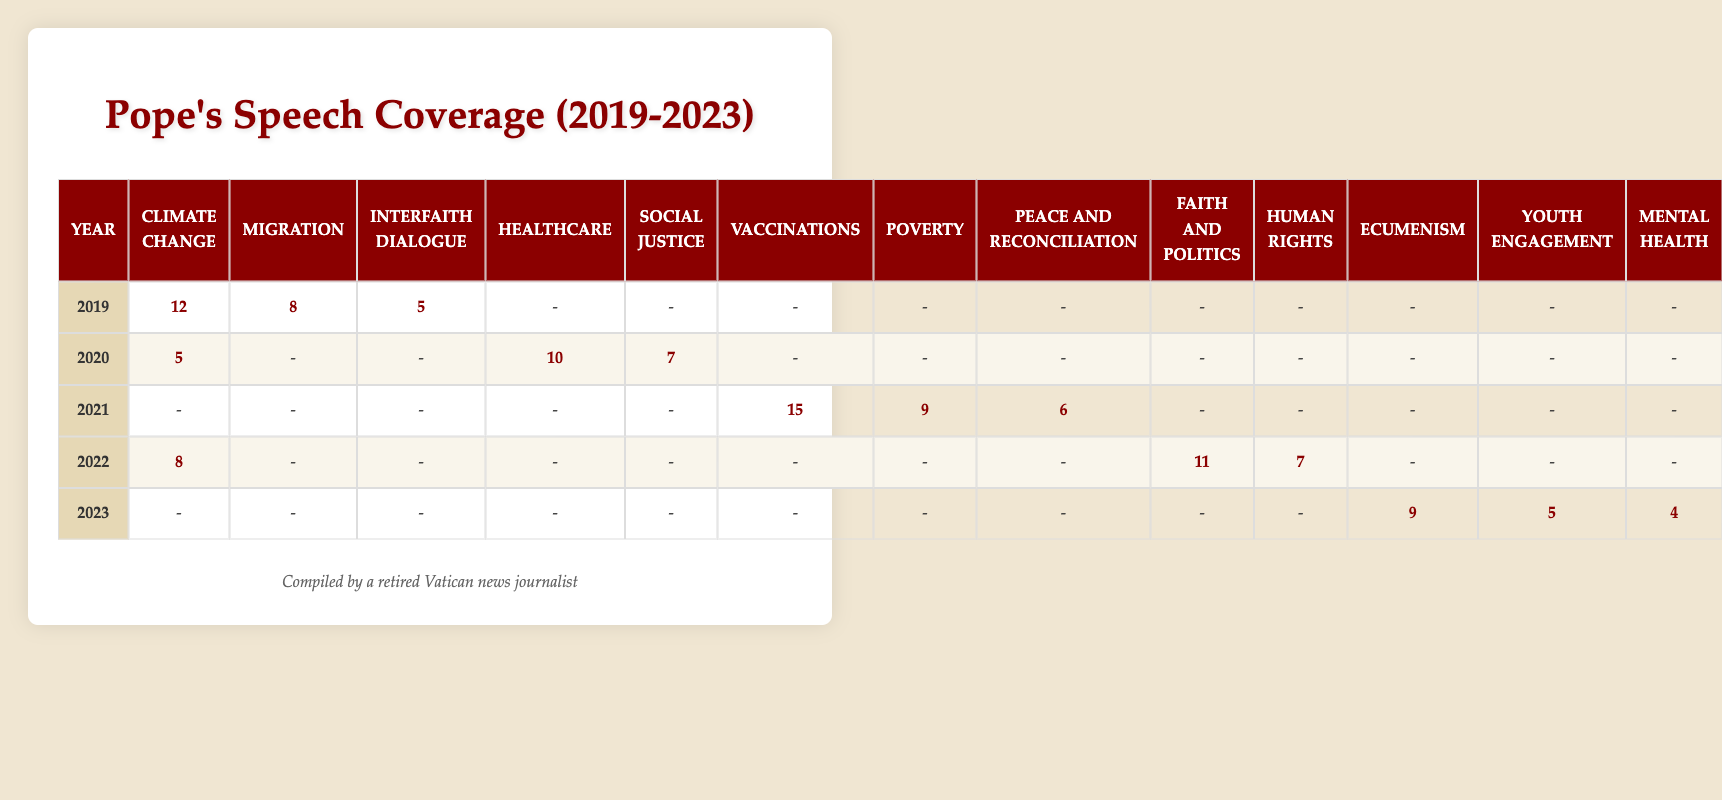What year had the highest speech count on Climate Change? In the table, the speech counts for Climate Change are 12 in 2019, 5 in 2020, no speeches in 2021, 8 in 2022, and no speeches in 2023. Comparing these values, 2019 has the highest count.
Answer: 2019 How many speeches did the Pope give on Healthcare from 2019 to 2023? The table shows that Healthcare has a speech count of 0 in 2019, 10 in 2020, 0 in 2021, 0 in 2022, and 0 in 2023. Summing these values gives 0 + 10 + 0 + 0 + 0 = 10.
Answer: 10 Did the Pope give more speeches on Migration than on Human Rights in 2022? In 2022, the speech counts are 0 for Migration and 7 for Human Rights. Since 0 is less than 7, the statement is false.
Answer: No What is the total number of speeches delivered on Poverty between 2020 and 2023? The speech counts for Poverty are 0 in 2019, 0 in 2020, 9 in 2021, 0 in 2022, and 0 in 2023. Therefore, the total number is 0 + 0 + 9 + 0 + 0 = 9.
Answer: 9 What was the average number of speeches on Ecumenism from 2019 to 2023? The table shows that the speech counts for Ecumenism are 0 in 2019, 0 in 2020, 0 in 2021, 0 in 2022, and 9 in 2023. To calculate the average, sum these (0 + 0 + 0 + 0 + 9 = 9) and divide by the number of years (5), giving 9/5 = 1.8.
Answer: 1.8 